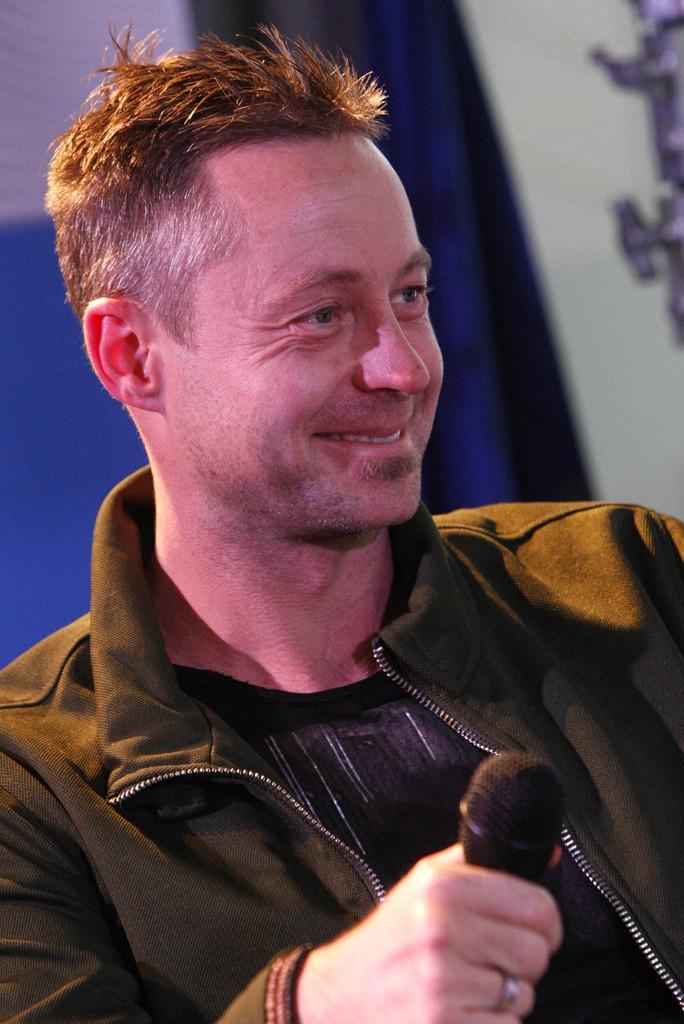Can you describe this image briefly? In this image there is a man standing. He is smiling. He is holding a microphone in his hand. Behind him there is a curtain to the wall. 